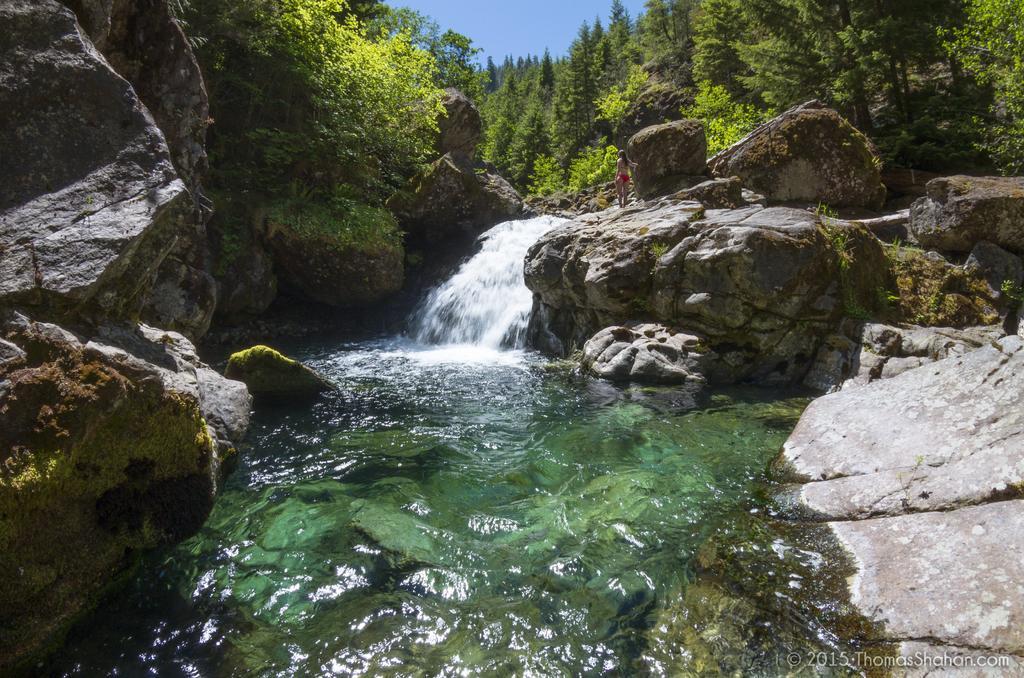Can you describe this image briefly? In this image I can see few rocks,water and trees. I can see a person is standing on the rock. The sky is in blue color. 